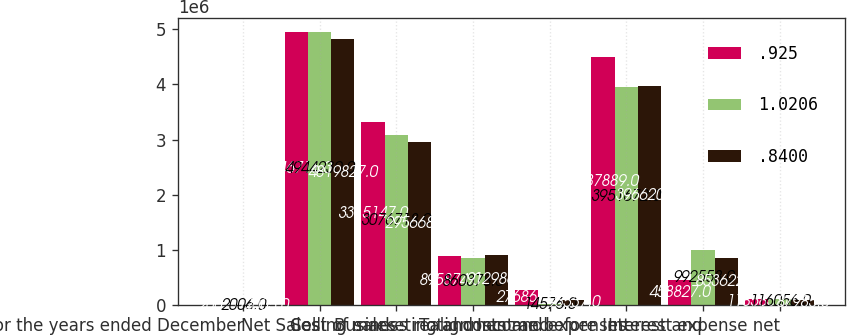<chart> <loc_0><loc_0><loc_500><loc_500><stacked_bar_chart><ecel><fcel>For the years ended December<fcel>Net Sales<fcel>Cost of sales<fcel>Selling marketing and<fcel>Business realignment and<fcel>Total costs and expenses<fcel>Income before Interest and<fcel>Interest expense net<nl><fcel>0.925<fcel>2007<fcel>4.94672e+06<fcel>3.31515e+06<fcel>895874<fcel>276868<fcel>4.48789e+06<fcel>458827<fcel>118585<nl><fcel>1.0206<fcel>2006<fcel>4.94423e+06<fcel>3.07672e+06<fcel>860378<fcel>14576<fcel>3.95167e+06<fcel>992558<fcel>116056<nl><fcel>0.84<fcel>2005<fcel>4.81983e+06<fcel>2.95668e+06<fcel>912986<fcel>96537<fcel>3.9662e+06<fcel>853622<fcel>87985<nl></chart> 